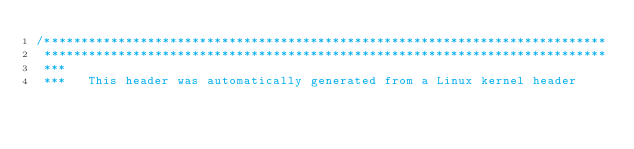<code> <loc_0><loc_0><loc_500><loc_500><_C_>/****************************************************************************
 ****************************************************************************
 ***
 ***   This header was automatically generated from a Linux kernel header</code> 